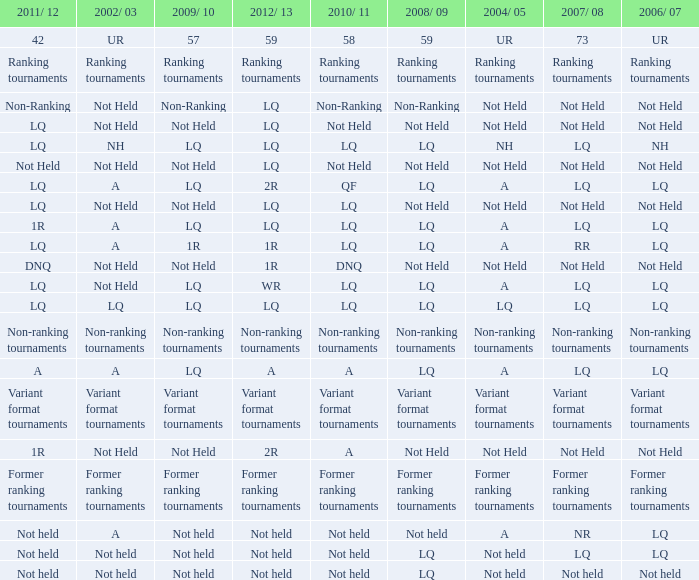Could you parse the entire table? {'header': ['2011/ 12', '2002/ 03', '2009/ 10', '2012/ 13', '2010/ 11', '2008/ 09', '2004/ 05', '2007/ 08', '2006/ 07'], 'rows': [['42', 'UR', '57', '59', '58', '59', 'UR', '73', 'UR'], ['Ranking tournaments', 'Ranking tournaments', 'Ranking tournaments', 'Ranking tournaments', 'Ranking tournaments', 'Ranking tournaments', 'Ranking tournaments', 'Ranking tournaments', 'Ranking tournaments'], ['Non-Ranking', 'Not Held', 'Non-Ranking', 'LQ', 'Non-Ranking', 'Non-Ranking', 'Not Held', 'Not Held', 'Not Held'], ['LQ', 'Not Held', 'Not Held', 'LQ', 'Not Held', 'Not Held', 'Not Held', 'Not Held', 'Not Held'], ['LQ', 'NH', 'LQ', 'LQ', 'LQ', 'LQ', 'NH', 'LQ', 'NH'], ['Not Held', 'Not Held', 'Not Held', 'LQ', 'Not Held', 'Not Held', 'Not Held', 'Not Held', 'Not Held'], ['LQ', 'A', 'LQ', '2R', 'QF', 'LQ', 'A', 'LQ', 'LQ'], ['LQ', 'Not Held', 'Not Held', 'LQ', 'LQ', 'Not Held', 'Not Held', 'Not Held', 'Not Held'], ['1R', 'A', 'LQ', 'LQ', 'LQ', 'LQ', 'A', 'LQ', 'LQ'], ['LQ', 'A', '1R', '1R', 'LQ', 'LQ', 'A', 'RR', 'LQ'], ['DNQ', 'Not Held', 'Not Held', '1R', 'DNQ', 'Not Held', 'Not Held', 'Not Held', 'Not Held'], ['LQ', 'Not Held', 'LQ', 'WR', 'LQ', 'LQ', 'A', 'LQ', 'LQ'], ['LQ', 'LQ', 'LQ', 'LQ', 'LQ', 'LQ', 'LQ', 'LQ', 'LQ'], ['Non-ranking tournaments', 'Non-ranking tournaments', 'Non-ranking tournaments', 'Non-ranking tournaments', 'Non-ranking tournaments', 'Non-ranking tournaments', 'Non-ranking tournaments', 'Non-ranking tournaments', 'Non-ranking tournaments'], ['A', 'A', 'LQ', 'A', 'A', 'LQ', 'A', 'LQ', 'LQ'], ['Variant format tournaments', 'Variant format tournaments', 'Variant format tournaments', 'Variant format tournaments', 'Variant format tournaments', 'Variant format tournaments', 'Variant format tournaments', 'Variant format tournaments', 'Variant format tournaments'], ['1R', 'Not Held', 'Not Held', '2R', 'A', 'Not Held', 'Not Held', 'Not Held', 'Not Held'], ['Former ranking tournaments', 'Former ranking tournaments', 'Former ranking tournaments', 'Former ranking tournaments', 'Former ranking tournaments', 'Former ranking tournaments', 'Former ranking tournaments', 'Former ranking tournaments', 'Former ranking tournaments'], ['Not held', 'A', 'Not held', 'Not held', 'Not held', 'Not held', 'A', 'NR', 'LQ'], ['Not held', 'Not held', 'Not held', 'Not held', 'Not held', 'LQ', 'Not held', 'LQ', 'LQ'], ['Not held', 'Not held', 'Not held', 'Not held', 'Not held', 'LQ', 'Not held', 'Not held', 'Not held']]} Name the 2010/11 with 2004/05 of not held and 2011/12 of non-ranking Non-Ranking. 